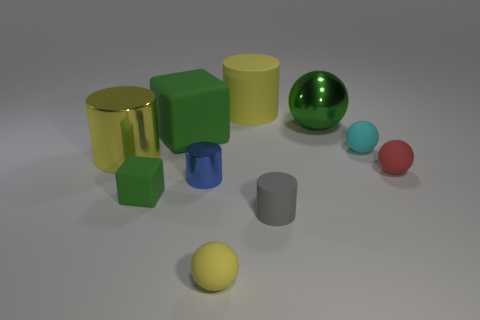Subtract all tiny blue metal cylinders. How many cylinders are left? 3 Subtract all yellow balls. How many yellow cylinders are left? 2 Subtract all gray cylinders. How many cylinders are left? 3 Subtract 2 cylinders. How many cylinders are left? 2 Subtract all purple cylinders. Subtract all gray spheres. How many cylinders are left? 4 Subtract all cylinders. How many objects are left? 6 Subtract all large purple cylinders. Subtract all tiny green rubber blocks. How many objects are left? 9 Add 6 tiny green rubber things. How many tiny green rubber things are left? 7 Add 2 large blue matte cylinders. How many large blue matte cylinders exist? 2 Subtract 1 yellow cylinders. How many objects are left? 9 